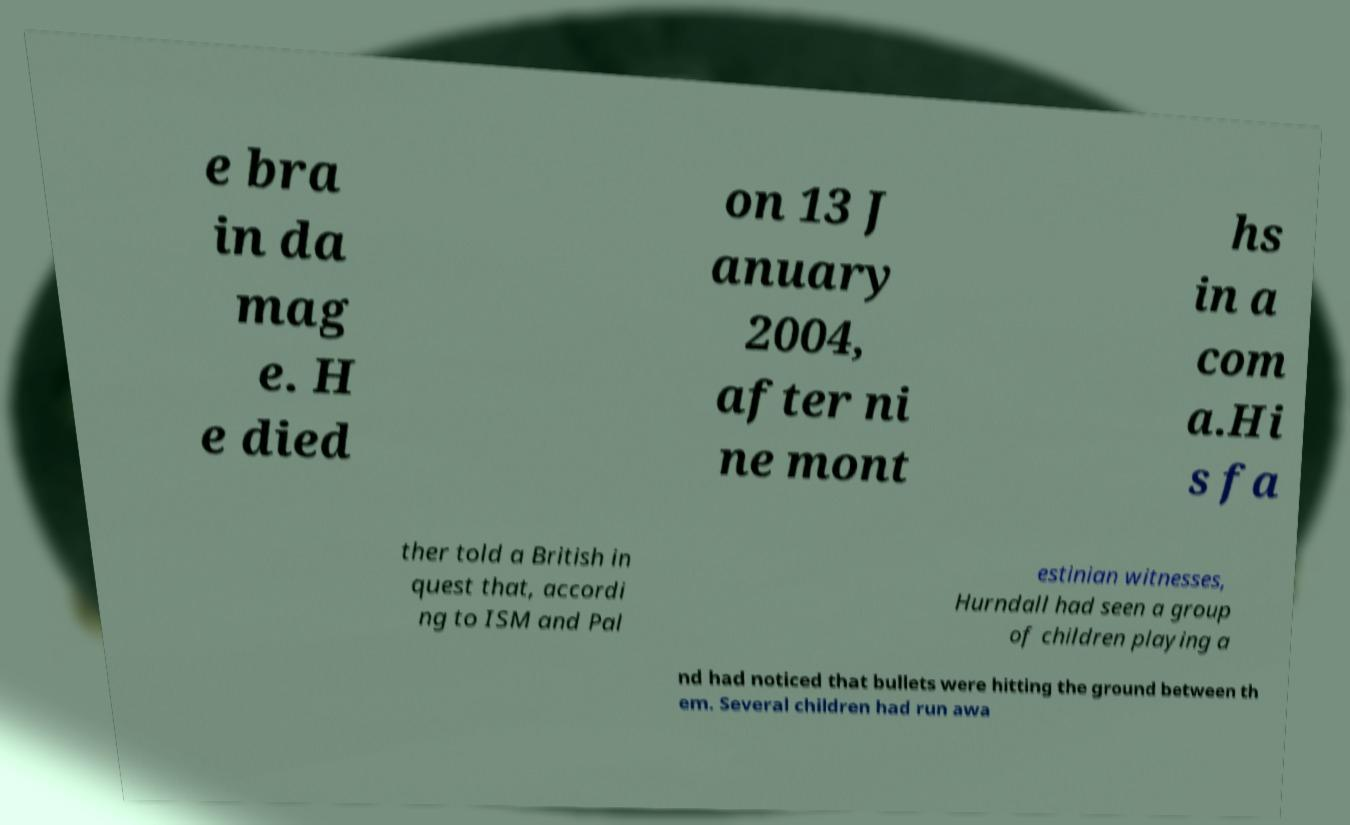Please read and relay the text visible in this image. What does it say? e bra in da mag e. H e died on 13 J anuary 2004, after ni ne mont hs in a com a.Hi s fa ther told a British in quest that, accordi ng to ISM and Pal estinian witnesses, Hurndall had seen a group of children playing a nd had noticed that bullets were hitting the ground between th em. Several children had run awa 